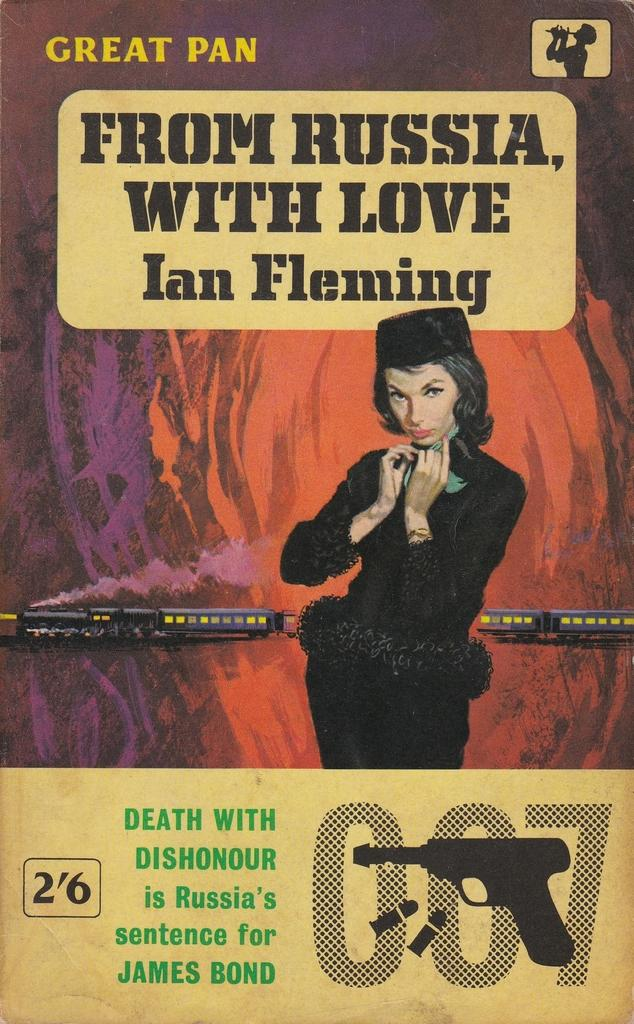What is depicted on the poster in the image? The poster features a woman wearing a black dress. What else can be seen in the image besides the poster? There is a train and text visible in the image. What type of degree is the woman holding in the image? There is no degree present in the image; the poster features a woman wearing a black dress. How many apples can be seen on the train in the image? There are no apples present on the train in the image. 